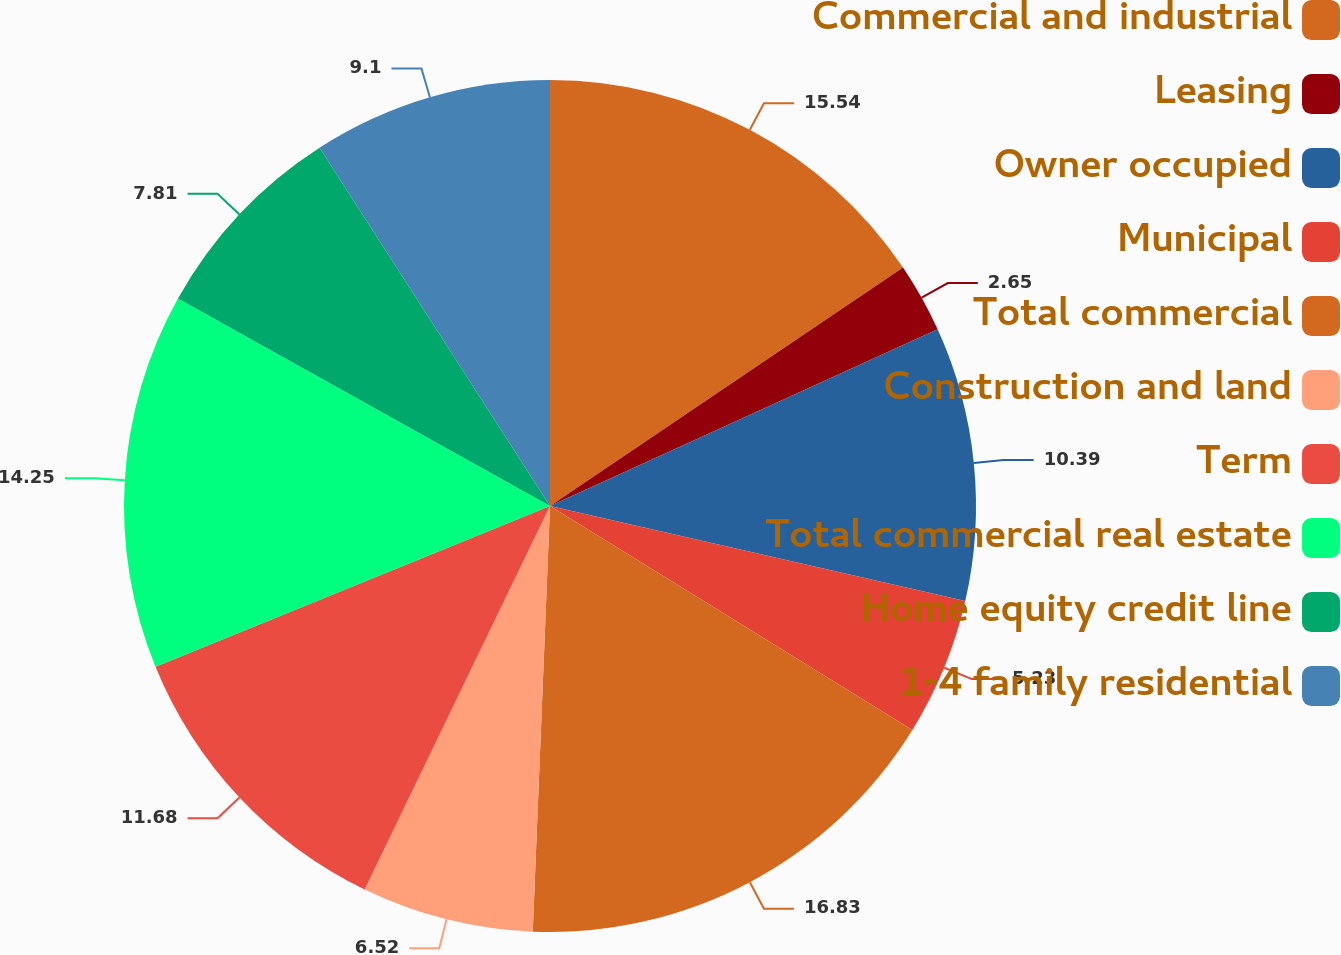Convert chart to OTSL. <chart><loc_0><loc_0><loc_500><loc_500><pie_chart><fcel>Commercial and industrial<fcel>Leasing<fcel>Owner occupied<fcel>Municipal<fcel>Total commercial<fcel>Construction and land<fcel>Term<fcel>Total commercial real estate<fcel>Home equity credit line<fcel>1-4 family residential<nl><fcel>15.55%<fcel>2.65%<fcel>10.39%<fcel>5.23%<fcel>16.84%<fcel>6.52%<fcel>11.68%<fcel>14.26%<fcel>7.81%<fcel>9.1%<nl></chart> 